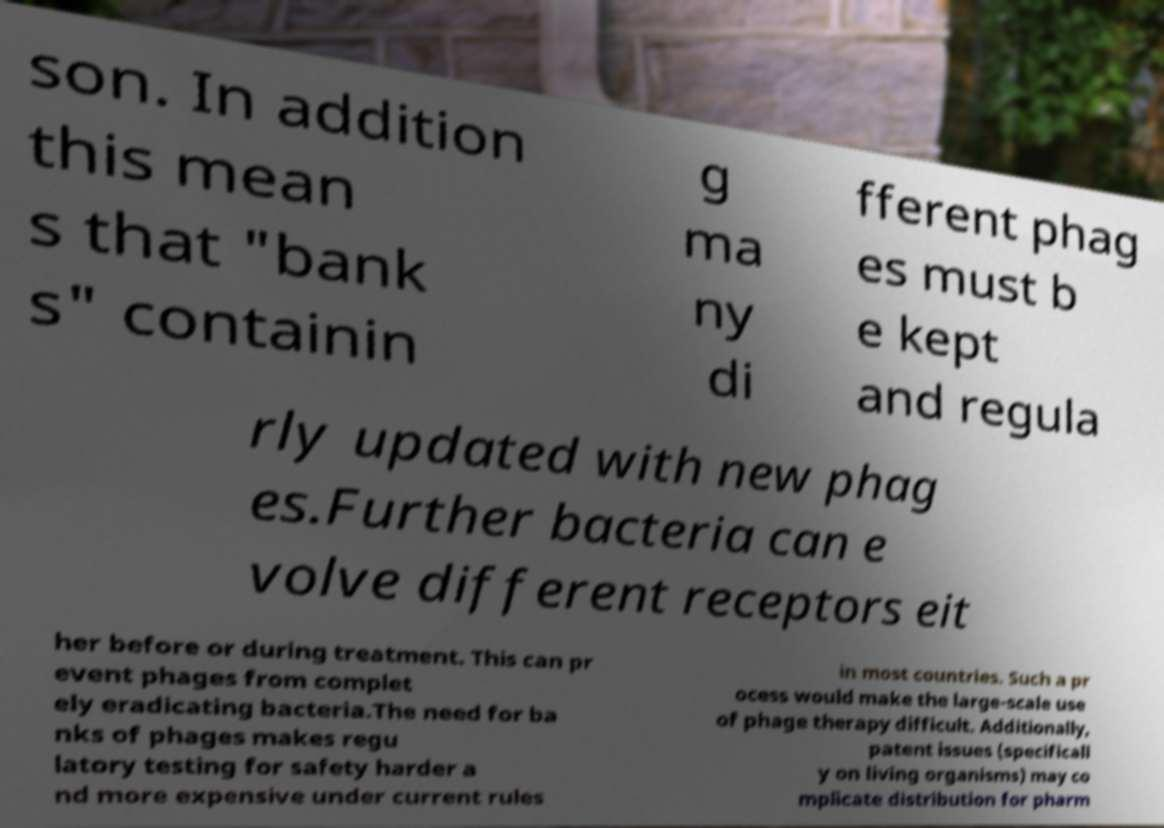For documentation purposes, I need the text within this image transcribed. Could you provide that? son. In addition this mean s that "bank s" containin g ma ny di fferent phag es must b e kept and regula rly updated with new phag es.Further bacteria can e volve different receptors eit her before or during treatment. This can pr event phages from complet ely eradicating bacteria.The need for ba nks of phages makes regu latory testing for safety harder a nd more expensive under current rules in most countries. Such a pr ocess would make the large-scale use of phage therapy difficult. Additionally, patent issues (specificall y on living organisms) may co mplicate distribution for pharm 